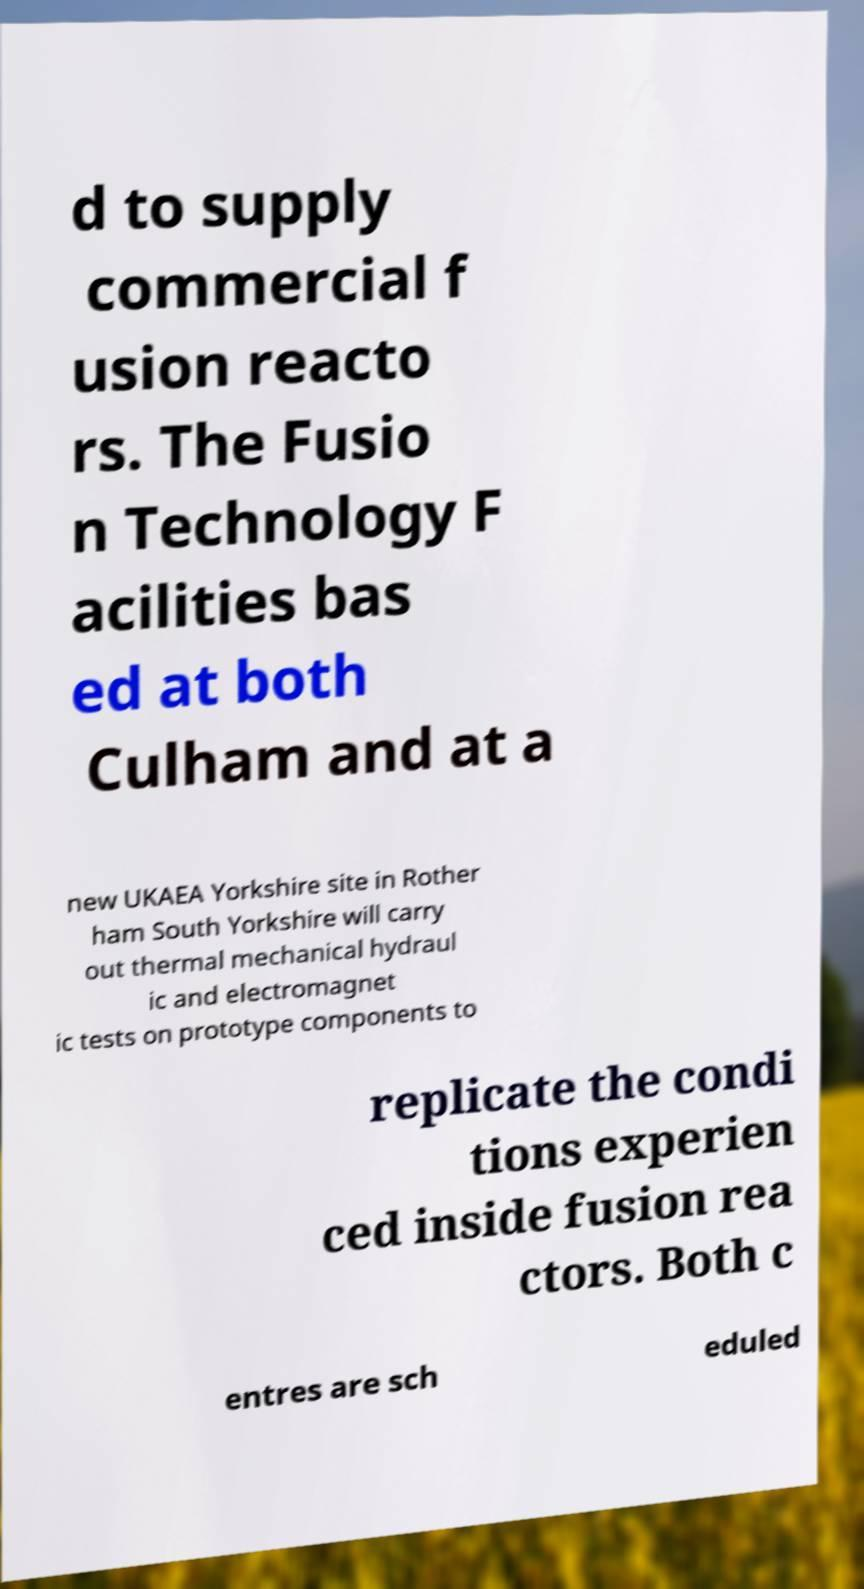Please identify and transcribe the text found in this image. d to supply commercial f usion reacto rs. The Fusio n Technology F acilities bas ed at both Culham and at a new UKAEA Yorkshire site in Rother ham South Yorkshire will carry out thermal mechanical hydraul ic and electromagnet ic tests on prototype components to replicate the condi tions experien ced inside fusion rea ctors. Both c entres are sch eduled 